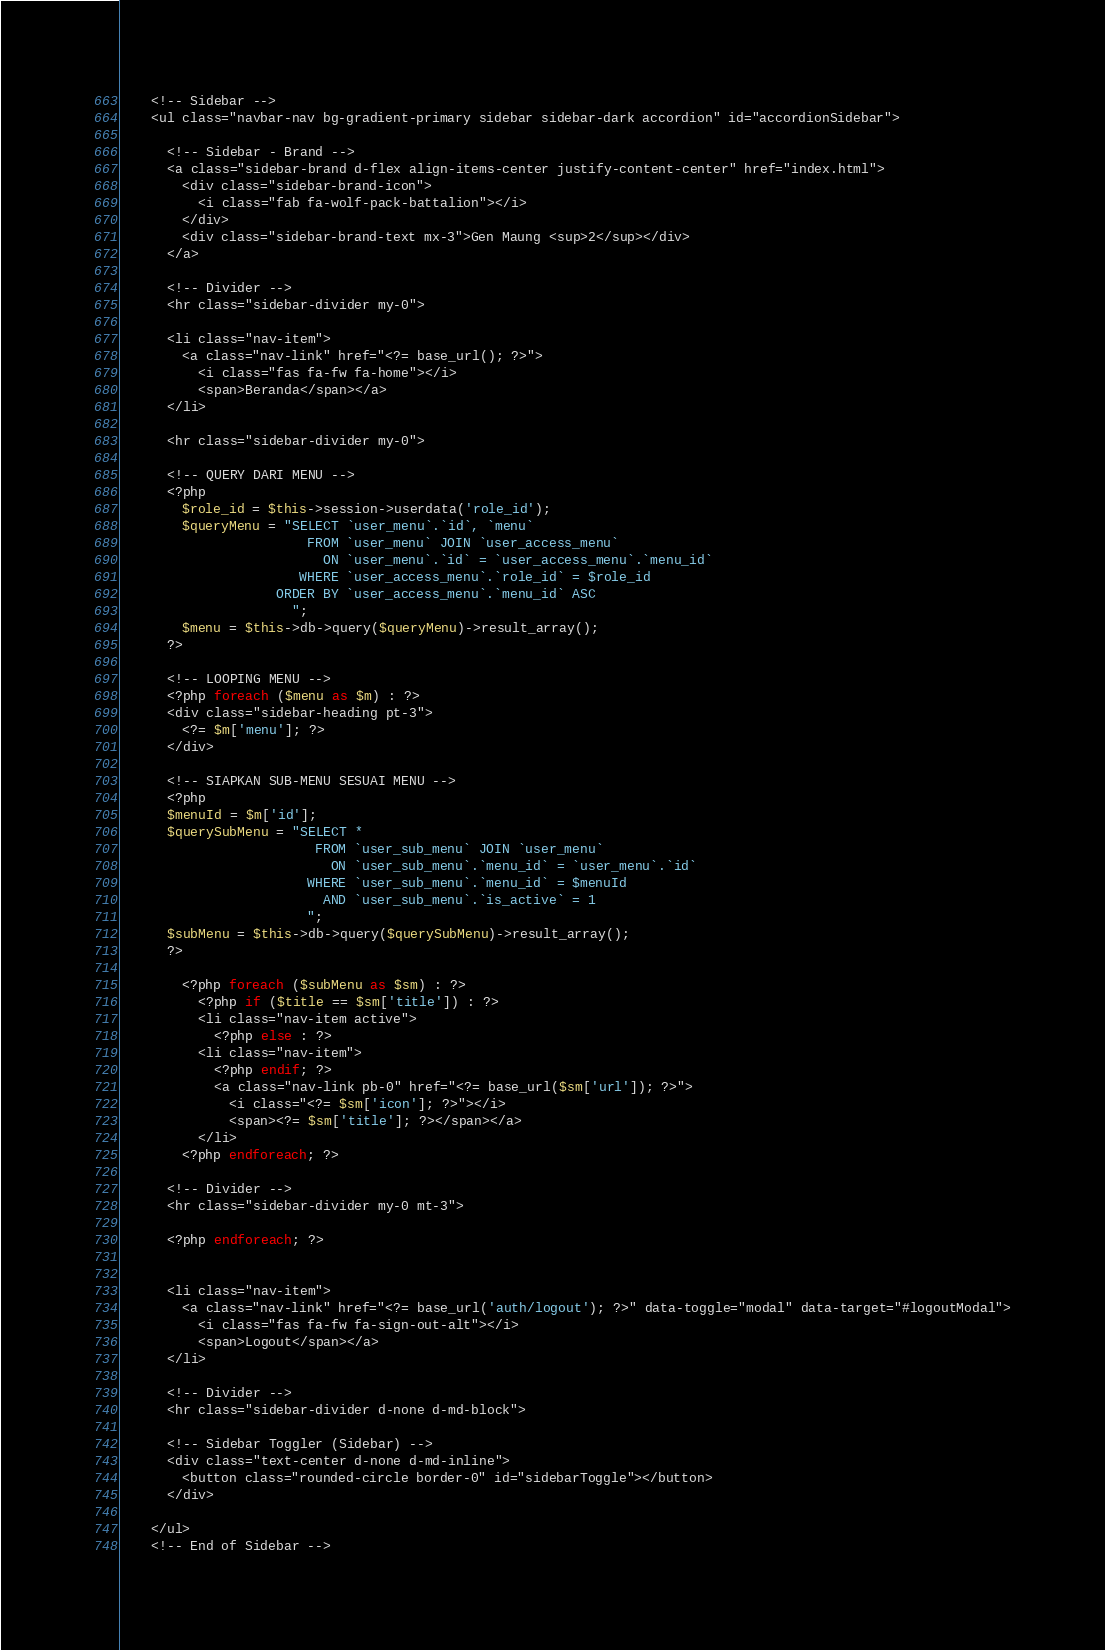<code> <loc_0><loc_0><loc_500><loc_500><_PHP_>
    <!-- Sidebar -->
    <ul class="navbar-nav bg-gradient-primary sidebar sidebar-dark accordion" id="accordionSidebar">

      <!-- Sidebar - Brand -->
      <a class="sidebar-brand d-flex align-items-center justify-content-center" href="index.html">
        <div class="sidebar-brand-icon">
          <i class="fab fa-wolf-pack-battalion"></i>
        </div>
        <div class="sidebar-brand-text mx-3">Gen Maung <sup>2</sup></div>
      </a>

      <!-- Divider -->
      <hr class="sidebar-divider my-0">

      <li class="nav-item">
        <a class="nav-link" href="<?= base_url(); ?>">
          <i class="fas fa-fw fa-home"></i>
          <span>Beranda</span></a>
      </li>

      <hr class="sidebar-divider my-0">

      <!-- QUERY DARI MENU -->
      <?php 
        $role_id = $this->session->userdata('role_id');
        $queryMenu = "SELECT `user_menu`.`id`, `menu`
                        FROM `user_menu` JOIN `user_access_menu`
                          ON `user_menu`.`id` = `user_access_menu`.`menu_id`
                       WHERE `user_access_menu`.`role_id` = $role_id
                    ORDER BY `user_access_menu`.`menu_id` ASC
                      ";
        $menu = $this->db->query($queryMenu)->result_array();
      ?>

      <!-- LOOPING MENU -->
      <?php foreach ($menu as $m) : ?>
      <div class="sidebar-heading pt-3">
        <?= $m['menu']; ?>
      </div>

      <!-- SIAPKAN SUB-MENU SESUAI MENU -->
      <?php 
      $menuId = $m['id'];
      $querySubMenu = "SELECT *
                         FROM `user_sub_menu` JOIN `user_menu` 
                           ON `user_sub_menu`.`menu_id` = `user_menu`.`id`
                        WHERE `user_sub_menu`.`menu_id` = $menuId
                          AND `user_sub_menu`.`is_active` = 1
                        ";
      $subMenu = $this->db->query($querySubMenu)->result_array();
      ?>

        <?php foreach ($subMenu as $sm) : ?>
          <?php if ($title == $sm['title']) : ?>
          <li class="nav-item active">  
            <?php else : ?>
          <li class="nav-item">
            <?php endif; ?>
            <a class="nav-link pb-0" href="<?= base_url($sm['url']); ?>">
              <i class="<?= $sm['icon']; ?>"></i>
              <span><?= $sm['title']; ?></span></a>
          </li>
        <?php endforeach; ?>

      <!-- Divider -->
      <hr class="sidebar-divider my-0 mt-3">

      <?php endforeach; ?>


      <li class="nav-item">
        <a class="nav-link" href="<?= base_url('auth/logout'); ?>" data-toggle="modal" data-target="#logoutModal">
          <i class="fas fa-fw fa-sign-out-alt"></i>
          <span>Logout</span></a>
      </li>

      <!-- Divider -->
      <hr class="sidebar-divider d-none d-md-block">

      <!-- Sidebar Toggler (Sidebar) -->
      <div class="text-center d-none d-md-inline">
        <button class="rounded-circle border-0" id="sidebarToggle"></button>
      </div>

    </ul>
    <!-- End of Sidebar --></code> 